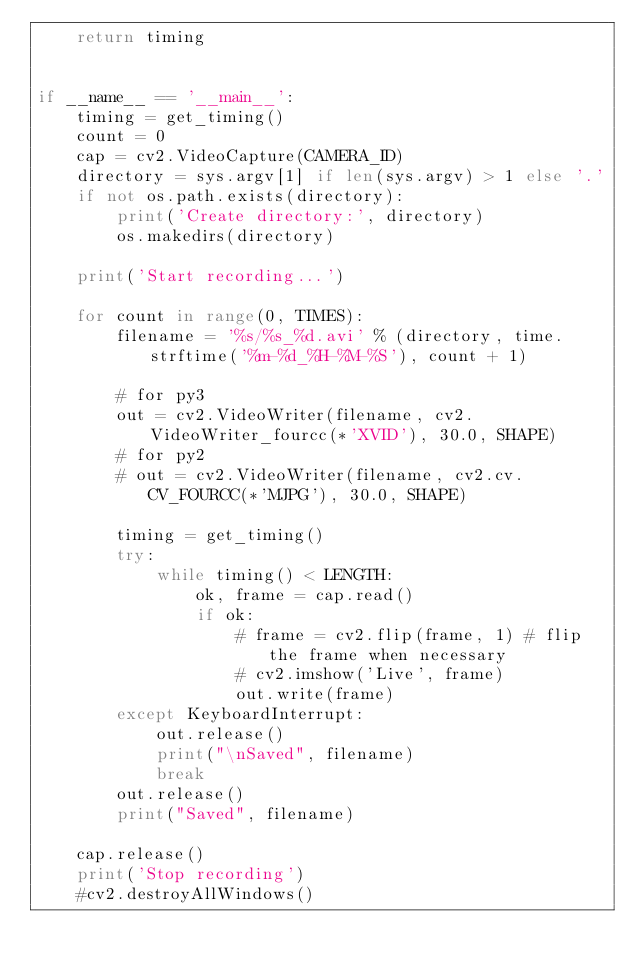<code> <loc_0><loc_0><loc_500><loc_500><_Python_>    return timing


if __name__ == '__main__':
    timing = get_timing()
    count = 0
    cap = cv2.VideoCapture(CAMERA_ID)
    directory = sys.argv[1] if len(sys.argv) > 1 else '.'
    if not os.path.exists(directory):
        print('Create directory:', directory)
        os.makedirs(directory)

    print('Start recording...')

    for count in range(0, TIMES):
        filename = '%s/%s_%d.avi' % (directory, time.strftime('%m-%d_%H-%M-%S'), count + 1)

        # for py3
        out = cv2.VideoWriter(filename, cv2.VideoWriter_fourcc(*'XVID'), 30.0, SHAPE)
        # for py2
        # out = cv2.VideoWriter(filename, cv2.cv.CV_FOURCC(*'MJPG'), 30.0, SHAPE)

        timing = get_timing()
        try:
            while timing() < LENGTH:
                ok, frame = cap.read()
                if ok:
                    # frame = cv2.flip(frame, 1) # flip the frame when necessary
                    # cv2.imshow('Live', frame)
                    out.write(frame)
        except KeyboardInterrupt:
            out.release()
            print("\nSaved", filename)
            break
        out.release()
        print("Saved", filename)

    cap.release()
    print('Stop recording')
    #cv2.destroyAllWindows()

</code> 